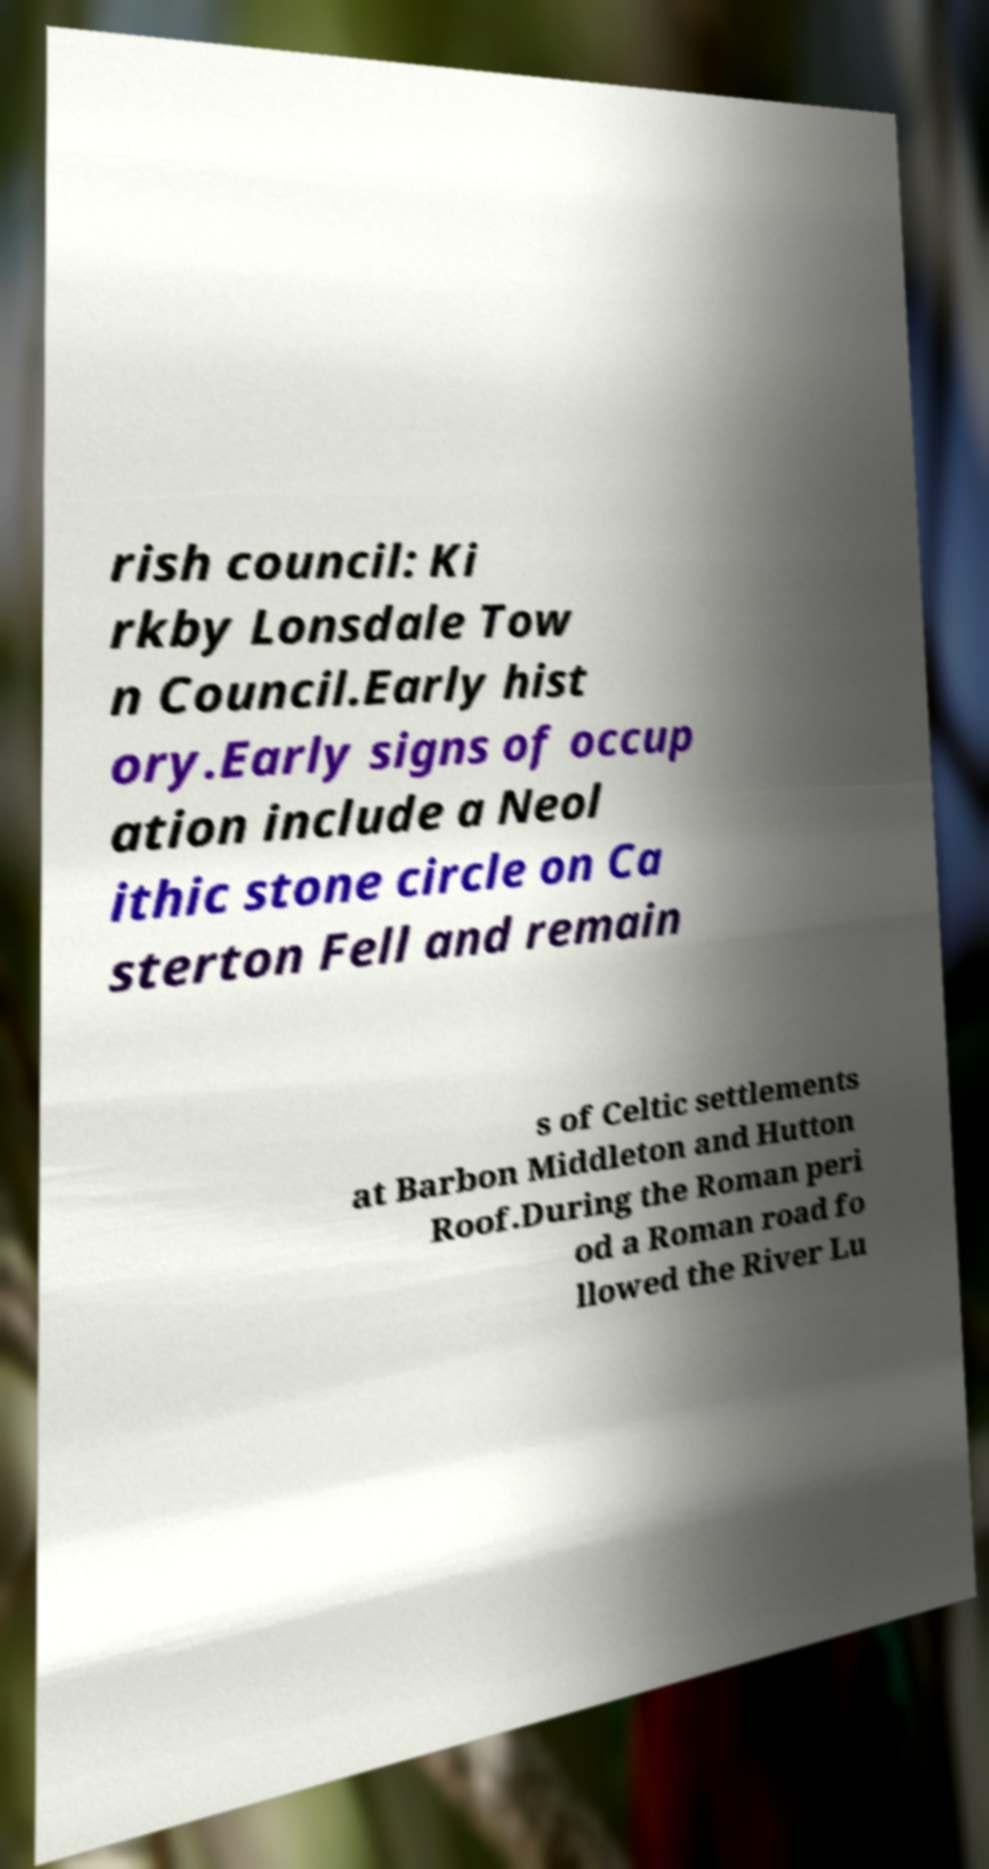Please identify and transcribe the text found in this image. rish council: Ki rkby Lonsdale Tow n Council.Early hist ory.Early signs of occup ation include a Neol ithic stone circle on Ca sterton Fell and remain s of Celtic settlements at Barbon Middleton and Hutton Roof.During the Roman peri od a Roman road fo llowed the River Lu 